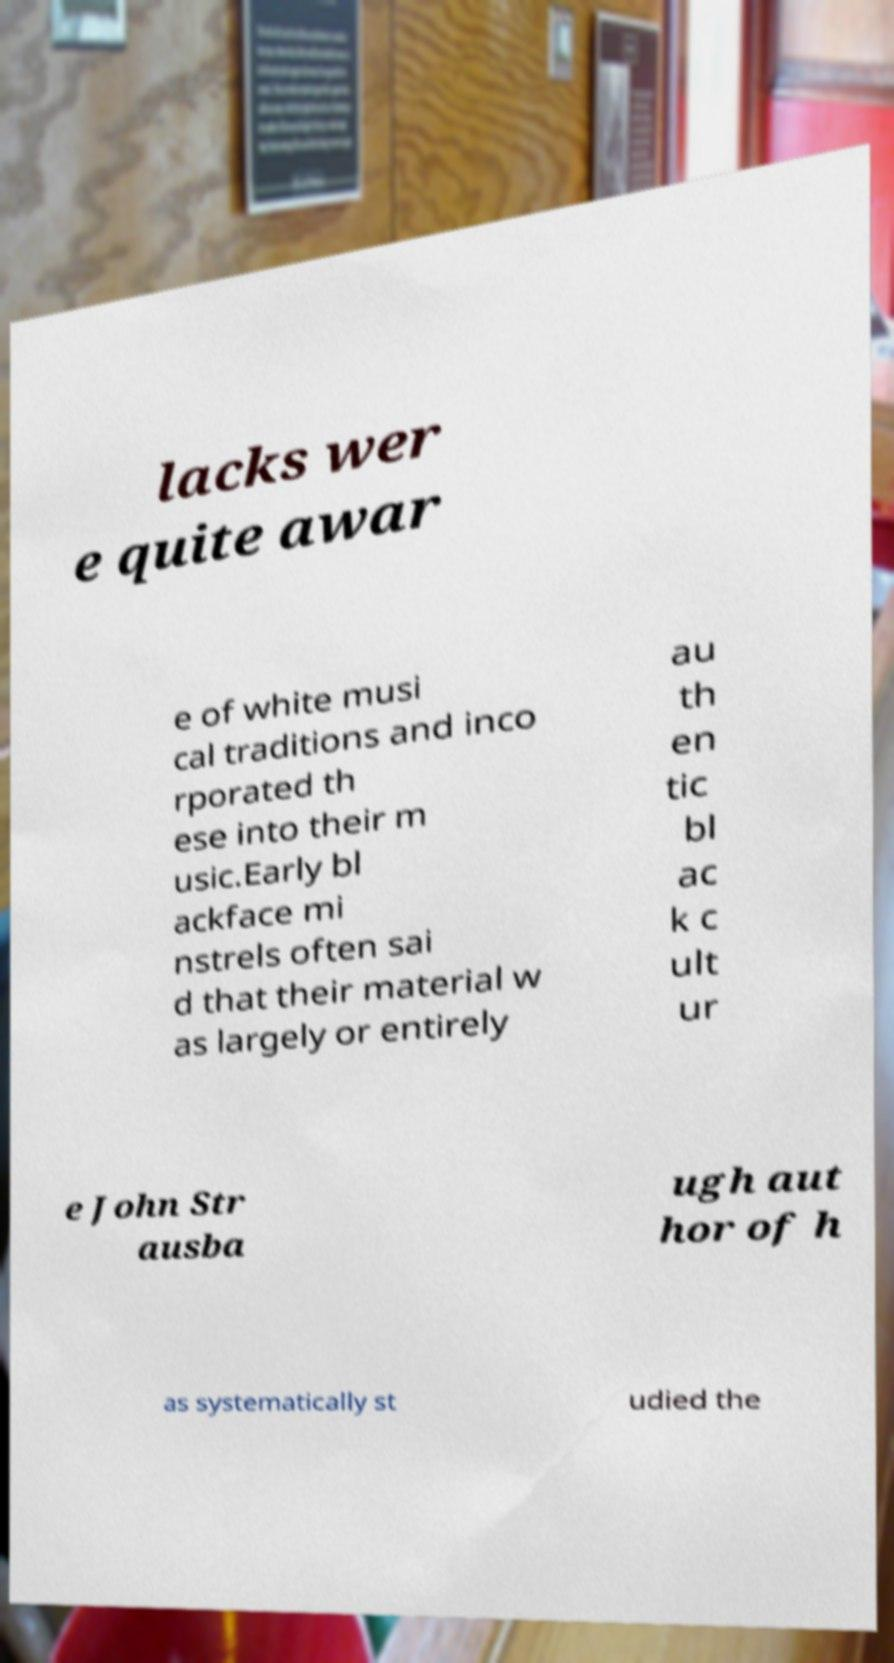I need the written content from this picture converted into text. Can you do that? lacks wer e quite awar e of white musi cal traditions and inco rporated th ese into their m usic.Early bl ackface mi nstrels often sai d that their material w as largely or entirely au th en tic bl ac k c ult ur e John Str ausba ugh aut hor of h as systematically st udied the 